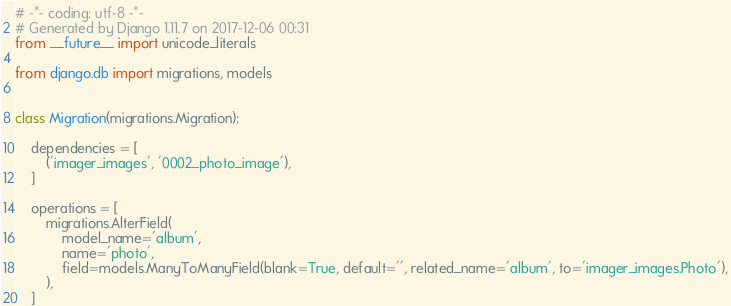Convert code to text. <code><loc_0><loc_0><loc_500><loc_500><_Python_># -*- coding: utf-8 -*-
# Generated by Django 1.11.7 on 2017-12-06 00:31
from __future__ import unicode_literals

from django.db import migrations, models


class Migration(migrations.Migration):

    dependencies = [
        ('imager_images', '0002_photo_image'),
    ]

    operations = [
        migrations.AlterField(
            model_name='album',
            name='photo',
            field=models.ManyToManyField(blank=True, default='', related_name='album', to='imager_images.Photo'),
        ),
    ]
</code> 